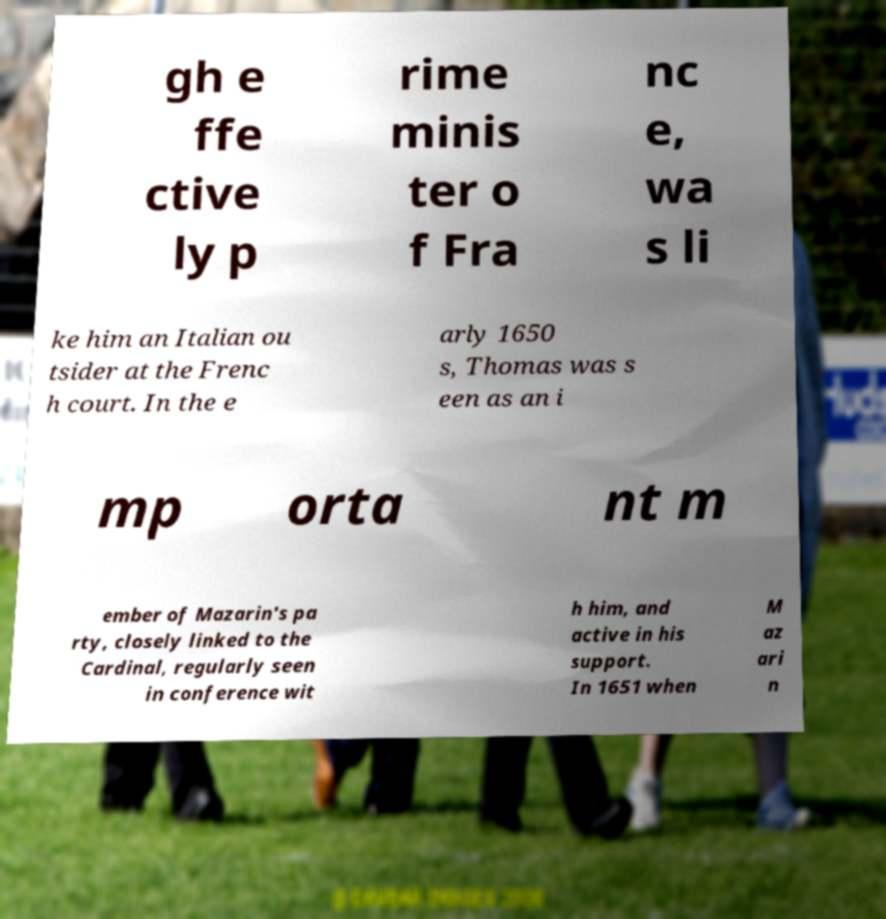Could you extract and type out the text from this image? gh e ffe ctive ly p rime minis ter o f Fra nc e, wa s li ke him an Italian ou tsider at the Frenc h court. In the e arly 1650 s, Thomas was s een as an i mp orta nt m ember of Mazarin's pa rty, closely linked to the Cardinal, regularly seen in conference wit h him, and active in his support. In 1651 when M az ari n 